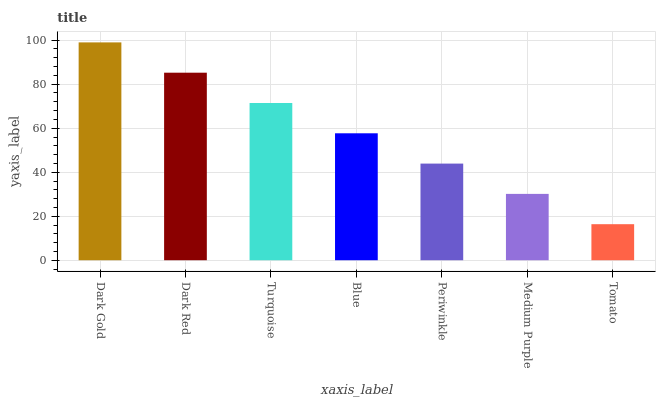Is Tomato the minimum?
Answer yes or no. Yes. Is Dark Gold the maximum?
Answer yes or no. Yes. Is Dark Red the minimum?
Answer yes or no. No. Is Dark Red the maximum?
Answer yes or no. No. Is Dark Gold greater than Dark Red?
Answer yes or no. Yes. Is Dark Red less than Dark Gold?
Answer yes or no. Yes. Is Dark Red greater than Dark Gold?
Answer yes or no. No. Is Dark Gold less than Dark Red?
Answer yes or no. No. Is Blue the high median?
Answer yes or no. Yes. Is Blue the low median?
Answer yes or no. Yes. Is Medium Purple the high median?
Answer yes or no. No. Is Tomato the low median?
Answer yes or no. No. 